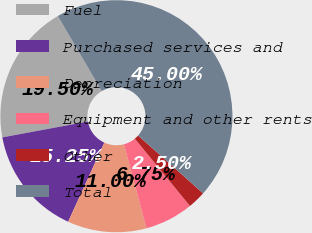Convert chart. <chart><loc_0><loc_0><loc_500><loc_500><pie_chart><fcel>Fuel<fcel>Purchased services and<fcel>Depreciation<fcel>Equipment and other rents<fcel>Other<fcel>Total<nl><fcel>19.5%<fcel>15.25%<fcel>11.0%<fcel>6.75%<fcel>2.5%<fcel>45.0%<nl></chart> 